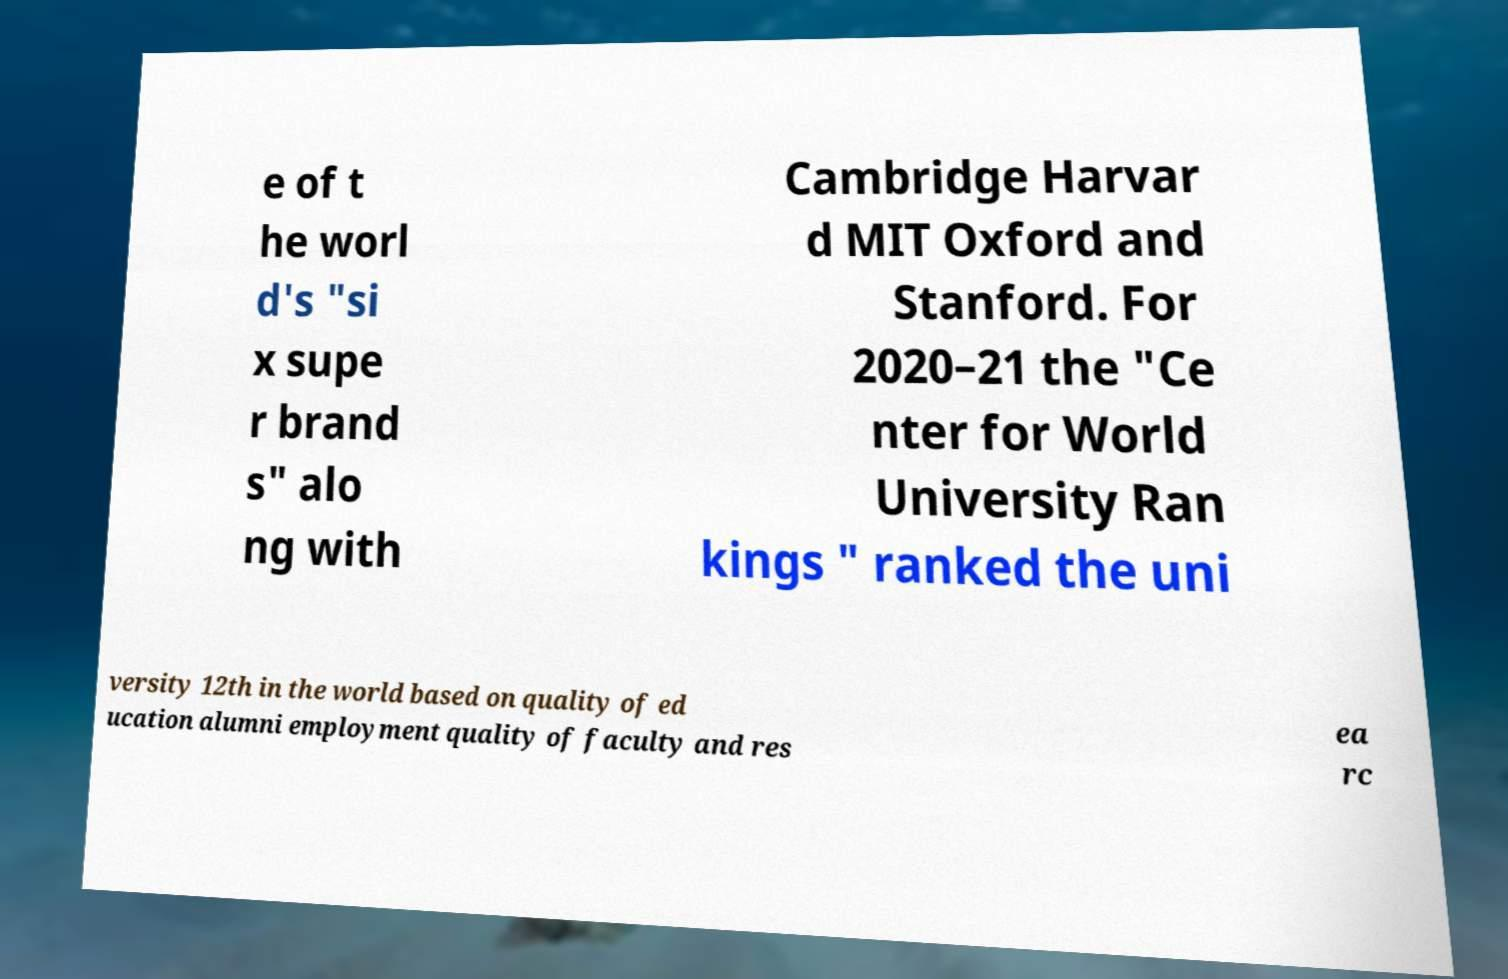Can you accurately transcribe the text from the provided image for me? e of t he worl d's "si x supe r brand s" alo ng with Cambridge Harvar d MIT Oxford and Stanford. For 2020–21 the "Ce nter for World University Ran kings " ranked the uni versity 12th in the world based on quality of ed ucation alumni employment quality of faculty and res ea rc 